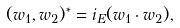Convert formula to latex. <formula><loc_0><loc_0><loc_500><loc_500>( w _ { 1 } , w _ { 2 } ) ^ { * } = i _ { E } ( w _ { 1 } \cdot w _ { 2 } ) ,</formula> 